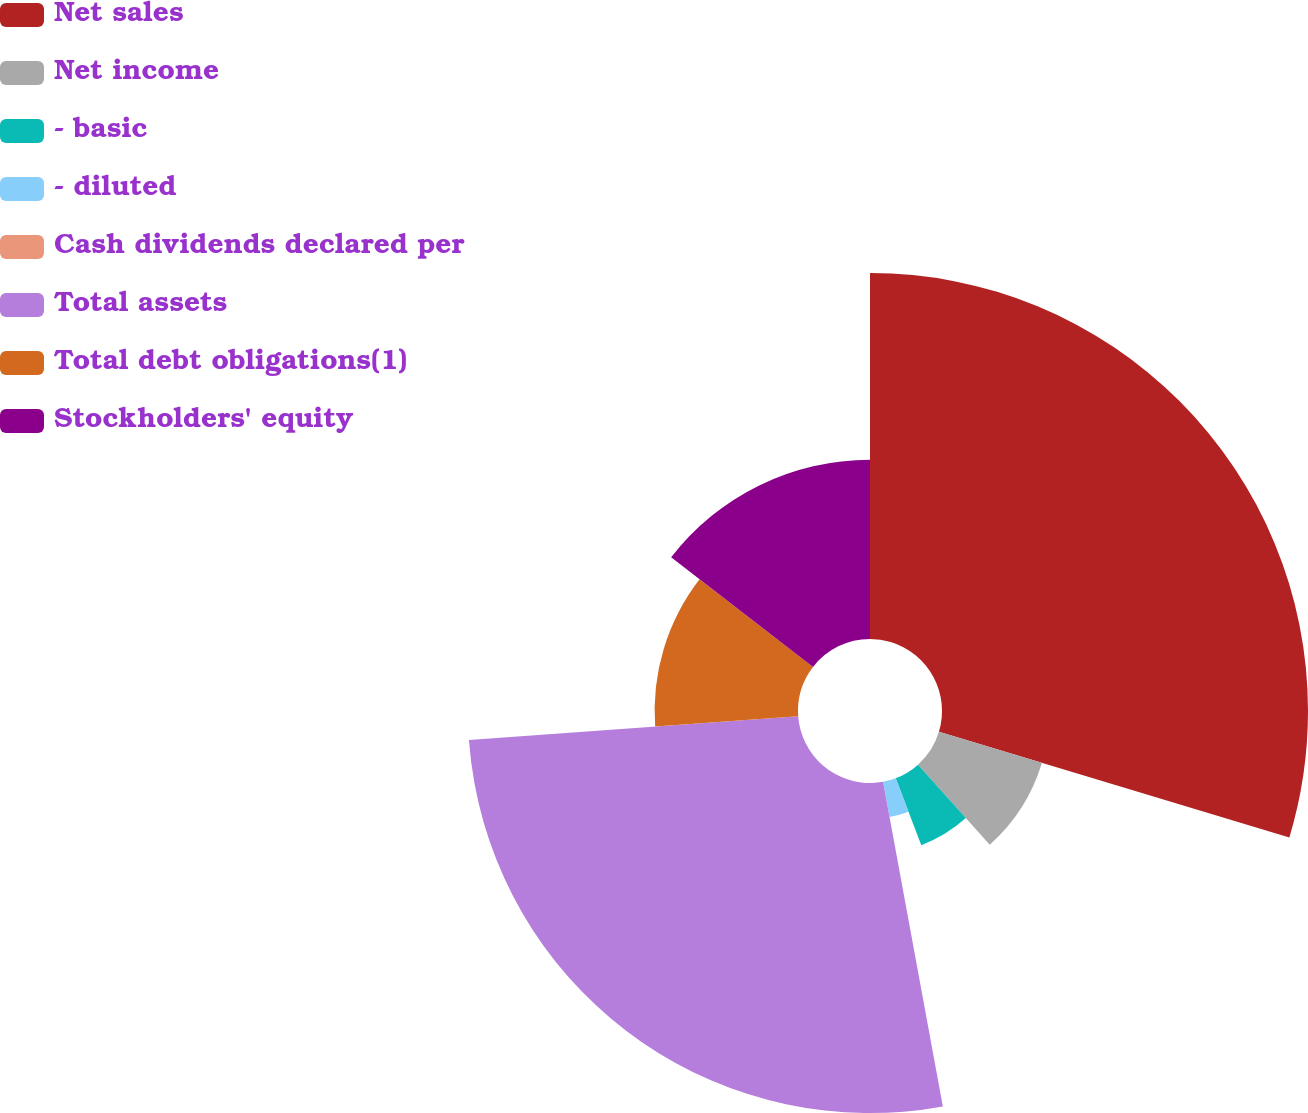Convert chart to OTSL. <chart><loc_0><loc_0><loc_500><loc_500><pie_chart><fcel>Net sales<fcel>Net income<fcel>- basic<fcel>- diluted<fcel>Cash dividends declared per<fcel>Total assets<fcel>Total debt obligations(1)<fcel>Stockholders' equity<nl><fcel>29.66%<fcel>8.72%<fcel>5.81%<fcel>2.91%<fcel>0.0%<fcel>26.75%<fcel>11.62%<fcel>14.53%<nl></chart> 